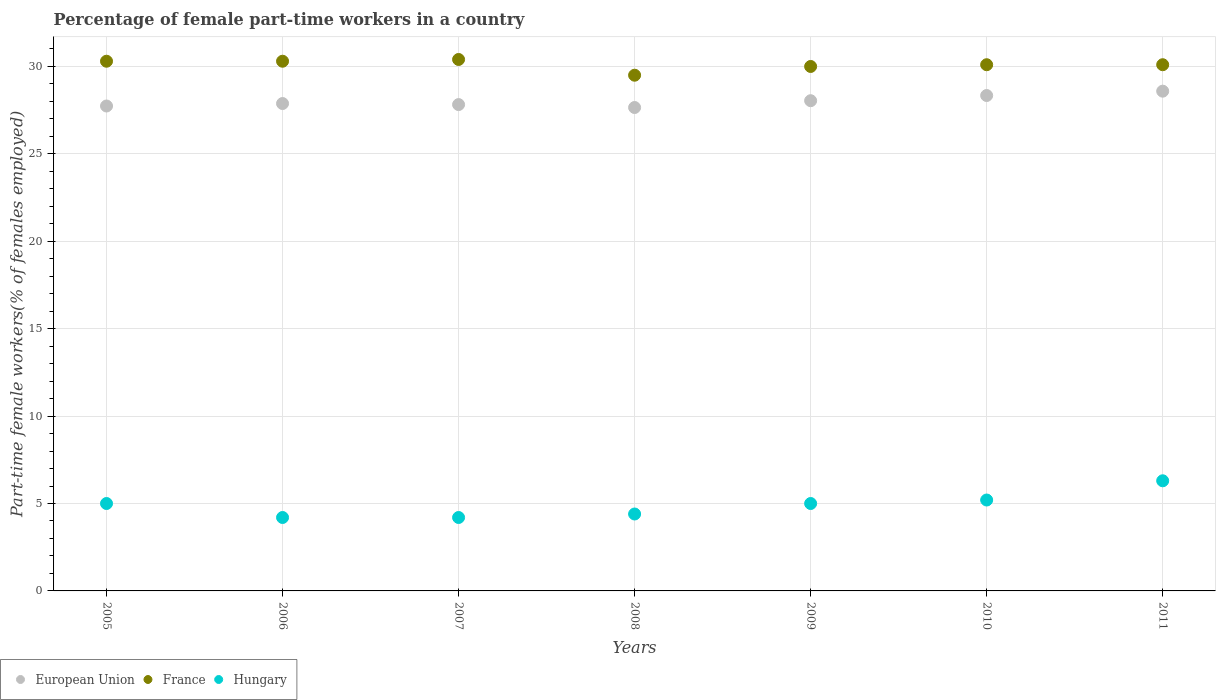What is the percentage of female part-time workers in Hungary in 2007?
Provide a succinct answer. 4.2. Across all years, what is the maximum percentage of female part-time workers in European Union?
Provide a succinct answer. 28.59. Across all years, what is the minimum percentage of female part-time workers in France?
Give a very brief answer. 29.5. What is the total percentage of female part-time workers in Hungary in the graph?
Your response must be concise. 34.3. What is the difference between the percentage of female part-time workers in Hungary in 2009 and that in 2010?
Ensure brevity in your answer.  -0.2. What is the difference between the percentage of female part-time workers in France in 2011 and the percentage of female part-time workers in European Union in 2005?
Make the answer very short. 2.36. What is the average percentage of female part-time workers in European Union per year?
Provide a short and direct response. 28.01. In the year 2007, what is the difference between the percentage of female part-time workers in European Union and percentage of female part-time workers in Hungary?
Make the answer very short. 23.62. What is the ratio of the percentage of female part-time workers in Hungary in 2007 to that in 2008?
Your response must be concise. 0.95. Is the percentage of female part-time workers in European Union in 2006 less than that in 2008?
Your answer should be compact. No. What is the difference between the highest and the second highest percentage of female part-time workers in France?
Offer a terse response. 0.1. What is the difference between the highest and the lowest percentage of female part-time workers in European Union?
Ensure brevity in your answer.  0.93. In how many years, is the percentage of female part-time workers in European Union greater than the average percentage of female part-time workers in European Union taken over all years?
Ensure brevity in your answer.  3. Is it the case that in every year, the sum of the percentage of female part-time workers in Hungary and percentage of female part-time workers in European Union  is greater than the percentage of female part-time workers in France?
Give a very brief answer. Yes. How many dotlines are there?
Ensure brevity in your answer.  3. How many years are there in the graph?
Give a very brief answer. 7. Are the values on the major ticks of Y-axis written in scientific E-notation?
Provide a succinct answer. No. Does the graph contain grids?
Offer a terse response. Yes. How many legend labels are there?
Your answer should be compact. 3. How are the legend labels stacked?
Provide a short and direct response. Horizontal. What is the title of the graph?
Ensure brevity in your answer.  Percentage of female part-time workers in a country. What is the label or title of the Y-axis?
Give a very brief answer. Part-time female workers(% of females employed). What is the Part-time female workers(% of females employed) in European Union in 2005?
Offer a very short reply. 27.74. What is the Part-time female workers(% of females employed) in France in 2005?
Ensure brevity in your answer.  30.3. What is the Part-time female workers(% of females employed) of Hungary in 2005?
Your response must be concise. 5. What is the Part-time female workers(% of females employed) in European Union in 2006?
Ensure brevity in your answer.  27.88. What is the Part-time female workers(% of females employed) in France in 2006?
Keep it short and to the point. 30.3. What is the Part-time female workers(% of females employed) in Hungary in 2006?
Make the answer very short. 4.2. What is the Part-time female workers(% of females employed) in European Union in 2007?
Give a very brief answer. 27.82. What is the Part-time female workers(% of females employed) in France in 2007?
Make the answer very short. 30.4. What is the Part-time female workers(% of females employed) of Hungary in 2007?
Offer a terse response. 4.2. What is the Part-time female workers(% of females employed) in European Union in 2008?
Give a very brief answer. 27.65. What is the Part-time female workers(% of females employed) of France in 2008?
Ensure brevity in your answer.  29.5. What is the Part-time female workers(% of females employed) of Hungary in 2008?
Give a very brief answer. 4.4. What is the Part-time female workers(% of females employed) of European Union in 2009?
Give a very brief answer. 28.04. What is the Part-time female workers(% of females employed) in France in 2009?
Your answer should be very brief. 30. What is the Part-time female workers(% of females employed) in Hungary in 2009?
Provide a short and direct response. 5. What is the Part-time female workers(% of females employed) of European Union in 2010?
Make the answer very short. 28.34. What is the Part-time female workers(% of females employed) of France in 2010?
Your answer should be compact. 30.1. What is the Part-time female workers(% of females employed) of Hungary in 2010?
Offer a very short reply. 5.2. What is the Part-time female workers(% of females employed) in European Union in 2011?
Your answer should be very brief. 28.59. What is the Part-time female workers(% of females employed) in France in 2011?
Your response must be concise. 30.1. What is the Part-time female workers(% of females employed) in Hungary in 2011?
Your answer should be compact. 6.3. Across all years, what is the maximum Part-time female workers(% of females employed) in European Union?
Provide a short and direct response. 28.59. Across all years, what is the maximum Part-time female workers(% of females employed) of France?
Offer a very short reply. 30.4. Across all years, what is the maximum Part-time female workers(% of females employed) of Hungary?
Ensure brevity in your answer.  6.3. Across all years, what is the minimum Part-time female workers(% of females employed) in European Union?
Give a very brief answer. 27.65. Across all years, what is the minimum Part-time female workers(% of females employed) in France?
Your answer should be compact. 29.5. Across all years, what is the minimum Part-time female workers(% of females employed) in Hungary?
Offer a terse response. 4.2. What is the total Part-time female workers(% of females employed) in European Union in the graph?
Make the answer very short. 196.06. What is the total Part-time female workers(% of females employed) in France in the graph?
Provide a short and direct response. 210.7. What is the total Part-time female workers(% of females employed) in Hungary in the graph?
Provide a short and direct response. 34.3. What is the difference between the Part-time female workers(% of females employed) of European Union in 2005 and that in 2006?
Ensure brevity in your answer.  -0.14. What is the difference between the Part-time female workers(% of females employed) of France in 2005 and that in 2006?
Your answer should be compact. 0. What is the difference between the Part-time female workers(% of females employed) of European Union in 2005 and that in 2007?
Make the answer very short. -0.08. What is the difference between the Part-time female workers(% of females employed) in France in 2005 and that in 2007?
Ensure brevity in your answer.  -0.1. What is the difference between the Part-time female workers(% of females employed) of Hungary in 2005 and that in 2007?
Provide a succinct answer. 0.8. What is the difference between the Part-time female workers(% of females employed) in European Union in 2005 and that in 2008?
Offer a terse response. 0.09. What is the difference between the Part-time female workers(% of females employed) in France in 2005 and that in 2008?
Offer a very short reply. 0.8. What is the difference between the Part-time female workers(% of females employed) of European Union in 2005 and that in 2009?
Your response must be concise. -0.3. What is the difference between the Part-time female workers(% of females employed) of European Union in 2005 and that in 2010?
Provide a succinct answer. -0.6. What is the difference between the Part-time female workers(% of females employed) in Hungary in 2005 and that in 2010?
Ensure brevity in your answer.  -0.2. What is the difference between the Part-time female workers(% of females employed) of European Union in 2005 and that in 2011?
Make the answer very short. -0.85. What is the difference between the Part-time female workers(% of females employed) of France in 2005 and that in 2011?
Your response must be concise. 0.2. What is the difference between the Part-time female workers(% of females employed) in Hungary in 2005 and that in 2011?
Provide a succinct answer. -1.3. What is the difference between the Part-time female workers(% of females employed) of European Union in 2006 and that in 2007?
Keep it short and to the point. 0.06. What is the difference between the Part-time female workers(% of females employed) in France in 2006 and that in 2007?
Give a very brief answer. -0.1. What is the difference between the Part-time female workers(% of females employed) in European Union in 2006 and that in 2008?
Keep it short and to the point. 0.23. What is the difference between the Part-time female workers(% of females employed) of Hungary in 2006 and that in 2008?
Your answer should be compact. -0.2. What is the difference between the Part-time female workers(% of females employed) of European Union in 2006 and that in 2009?
Give a very brief answer. -0.16. What is the difference between the Part-time female workers(% of females employed) of France in 2006 and that in 2009?
Offer a very short reply. 0.3. What is the difference between the Part-time female workers(% of females employed) of European Union in 2006 and that in 2010?
Your answer should be compact. -0.46. What is the difference between the Part-time female workers(% of females employed) in France in 2006 and that in 2010?
Provide a short and direct response. 0.2. What is the difference between the Part-time female workers(% of females employed) of European Union in 2006 and that in 2011?
Provide a succinct answer. -0.71. What is the difference between the Part-time female workers(% of females employed) in European Union in 2007 and that in 2008?
Offer a very short reply. 0.17. What is the difference between the Part-time female workers(% of females employed) of France in 2007 and that in 2008?
Keep it short and to the point. 0.9. What is the difference between the Part-time female workers(% of females employed) of European Union in 2007 and that in 2009?
Your answer should be compact. -0.22. What is the difference between the Part-time female workers(% of females employed) in Hungary in 2007 and that in 2009?
Make the answer very short. -0.8. What is the difference between the Part-time female workers(% of females employed) of European Union in 2007 and that in 2010?
Your answer should be very brief. -0.52. What is the difference between the Part-time female workers(% of females employed) in France in 2007 and that in 2010?
Make the answer very short. 0.3. What is the difference between the Part-time female workers(% of females employed) of European Union in 2007 and that in 2011?
Your answer should be compact. -0.77. What is the difference between the Part-time female workers(% of females employed) of Hungary in 2007 and that in 2011?
Provide a short and direct response. -2.1. What is the difference between the Part-time female workers(% of females employed) of European Union in 2008 and that in 2009?
Your answer should be very brief. -0.39. What is the difference between the Part-time female workers(% of females employed) in European Union in 2008 and that in 2010?
Make the answer very short. -0.69. What is the difference between the Part-time female workers(% of females employed) of Hungary in 2008 and that in 2010?
Offer a very short reply. -0.8. What is the difference between the Part-time female workers(% of females employed) in European Union in 2008 and that in 2011?
Provide a succinct answer. -0.93. What is the difference between the Part-time female workers(% of females employed) in Hungary in 2008 and that in 2011?
Make the answer very short. -1.9. What is the difference between the Part-time female workers(% of females employed) of European Union in 2009 and that in 2010?
Offer a very short reply. -0.3. What is the difference between the Part-time female workers(% of females employed) in France in 2009 and that in 2010?
Your response must be concise. -0.1. What is the difference between the Part-time female workers(% of females employed) in European Union in 2009 and that in 2011?
Offer a terse response. -0.55. What is the difference between the Part-time female workers(% of females employed) in France in 2009 and that in 2011?
Make the answer very short. -0.1. What is the difference between the Part-time female workers(% of females employed) in European Union in 2010 and that in 2011?
Your response must be concise. -0.25. What is the difference between the Part-time female workers(% of females employed) in European Union in 2005 and the Part-time female workers(% of females employed) in France in 2006?
Give a very brief answer. -2.56. What is the difference between the Part-time female workers(% of females employed) of European Union in 2005 and the Part-time female workers(% of females employed) of Hungary in 2006?
Your answer should be compact. 23.54. What is the difference between the Part-time female workers(% of females employed) in France in 2005 and the Part-time female workers(% of females employed) in Hungary in 2006?
Offer a very short reply. 26.1. What is the difference between the Part-time female workers(% of females employed) in European Union in 2005 and the Part-time female workers(% of females employed) in France in 2007?
Provide a short and direct response. -2.66. What is the difference between the Part-time female workers(% of females employed) in European Union in 2005 and the Part-time female workers(% of females employed) in Hungary in 2007?
Make the answer very short. 23.54. What is the difference between the Part-time female workers(% of females employed) of France in 2005 and the Part-time female workers(% of females employed) of Hungary in 2007?
Your answer should be very brief. 26.1. What is the difference between the Part-time female workers(% of females employed) of European Union in 2005 and the Part-time female workers(% of females employed) of France in 2008?
Your answer should be very brief. -1.76. What is the difference between the Part-time female workers(% of females employed) of European Union in 2005 and the Part-time female workers(% of females employed) of Hungary in 2008?
Provide a short and direct response. 23.34. What is the difference between the Part-time female workers(% of females employed) in France in 2005 and the Part-time female workers(% of females employed) in Hungary in 2008?
Offer a terse response. 25.9. What is the difference between the Part-time female workers(% of females employed) of European Union in 2005 and the Part-time female workers(% of females employed) of France in 2009?
Keep it short and to the point. -2.26. What is the difference between the Part-time female workers(% of females employed) in European Union in 2005 and the Part-time female workers(% of females employed) in Hungary in 2009?
Your answer should be compact. 22.74. What is the difference between the Part-time female workers(% of females employed) in France in 2005 and the Part-time female workers(% of females employed) in Hungary in 2009?
Your response must be concise. 25.3. What is the difference between the Part-time female workers(% of females employed) of European Union in 2005 and the Part-time female workers(% of females employed) of France in 2010?
Your answer should be very brief. -2.36. What is the difference between the Part-time female workers(% of females employed) of European Union in 2005 and the Part-time female workers(% of females employed) of Hungary in 2010?
Provide a short and direct response. 22.54. What is the difference between the Part-time female workers(% of females employed) in France in 2005 and the Part-time female workers(% of females employed) in Hungary in 2010?
Offer a terse response. 25.1. What is the difference between the Part-time female workers(% of females employed) in European Union in 2005 and the Part-time female workers(% of females employed) in France in 2011?
Keep it short and to the point. -2.36. What is the difference between the Part-time female workers(% of females employed) of European Union in 2005 and the Part-time female workers(% of females employed) of Hungary in 2011?
Provide a succinct answer. 21.44. What is the difference between the Part-time female workers(% of females employed) in European Union in 2006 and the Part-time female workers(% of females employed) in France in 2007?
Your answer should be compact. -2.52. What is the difference between the Part-time female workers(% of females employed) in European Union in 2006 and the Part-time female workers(% of females employed) in Hungary in 2007?
Your response must be concise. 23.68. What is the difference between the Part-time female workers(% of females employed) of France in 2006 and the Part-time female workers(% of females employed) of Hungary in 2007?
Offer a very short reply. 26.1. What is the difference between the Part-time female workers(% of females employed) of European Union in 2006 and the Part-time female workers(% of females employed) of France in 2008?
Give a very brief answer. -1.62. What is the difference between the Part-time female workers(% of females employed) of European Union in 2006 and the Part-time female workers(% of females employed) of Hungary in 2008?
Keep it short and to the point. 23.48. What is the difference between the Part-time female workers(% of females employed) of France in 2006 and the Part-time female workers(% of females employed) of Hungary in 2008?
Give a very brief answer. 25.9. What is the difference between the Part-time female workers(% of females employed) of European Union in 2006 and the Part-time female workers(% of females employed) of France in 2009?
Your response must be concise. -2.12. What is the difference between the Part-time female workers(% of females employed) in European Union in 2006 and the Part-time female workers(% of females employed) in Hungary in 2009?
Offer a terse response. 22.88. What is the difference between the Part-time female workers(% of females employed) in France in 2006 and the Part-time female workers(% of females employed) in Hungary in 2009?
Your answer should be very brief. 25.3. What is the difference between the Part-time female workers(% of females employed) in European Union in 2006 and the Part-time female workers(% of females employed) in France in 2010?
Make the answer very short. -2.22. What is the difference between the Part-time female workers(% of females employed) in European Union in 2006 and the Part-time female workers(% of females employed) in Hungary in 2010?
Your answer should be very brief. 22.68. What is the difference between the Part-time female workers(% of females employed) in France in 2006 and the Part-time female workers(% of females employed) in Hungary in 2010?
Offer a terse response. 25.1. What is the difference between the Part-time female workers(% of females employed) of European Union in 2006 and the Part-time female workers(% of females employed) of France in 2011?
Your answer should be compact. -2.22. What is the difference between the Part-time female workers(% of females employed) in European Union in 2006 and the Part-time female workers(% of females employed) in Hungary in 2011?
Provide a succinct answer. 21.58. What is the difference between the Part-time female workers(% of females employed) in France in 2006 and the Part-time female workers(% of females employed) in Hungary in 2011?
Provide a succinct answer. 24. What is the difference between the Part-time female workers(% of females employed) of European Union in 2007 and the Part-time female workers(% of females employed) of France in 2008?
Offer a terse response. -1.68. What is the difference between the Part-time female workers(% of females employed) of European Union in 2007 and the Part-time female workers(% of females employed) of Hungary in 2008?
Your answer should be compact. 23.42. What is the difference between the Part-time female workers(% of females employed) in France in 2007 and the Part-time female workers(% of females employed) in Hungary in 2008?
Provide a short and direct response. 26. What is the difference between the Part-time female workers(% of females employed) of European Union in 2007 and the Part-time female workers(% of females employed) of France in 2009?
Keep it short and to the point. -2.18. What is the difference between the Part-time female workers(% of females employed) of European Union in 2007 and the Part-time female workers(% of females employed) of Hungary in 2009?
Your answer should be very brief. 22.82. What is the difference between the Part-time female workers(% of females employed) in France in 2007 and the Part-time female workers(% of females employed) in Hungary in 2009?
Your answer should be very brief. 25.4. What is the difference between the Part-time female workers(% of females employed) of European Union in 2007 and the Part-time female workers(% of females employed) of France in 2010?
Your answer should be compact. -2.28. What is the difference between the Part-time female workers(% of females employed) of European Union in 2007 and the Part-time female workers(% of females employed) of Hungary in 2010?
Provide a succinct answer. 22.62. What is the difference between the Part-time female workers(% of females employed) in France in 2007 and the Part-time female workers(% of females employed) in Hungary in 2010?
Provide a succinct answer. 25.2. What is the difference between the Part-time female workers(% of females employed) in European Union in 2007 and the Part-time female workers(% of females employed) in France in 2011?
Provide a succinct answer. -2.28. What is the difference between the Part-time female workers(% of females employed) of European Union in 2007 and the Part-time female workers(% of females employed) of Hungary in 2011?
Your response must be concise. 21.52. What is the difference between the Part-time female workers(% of females employed) in France in 2007 and the Part-time female workers(% of females employed) in Hungary in 2011?
Your response must be concise. 24.1. What is the difference between the Part-time female workers(% of females employed) in European Union in 2008 and the Part-time female workers(% of females employed) in France in 2009?
Offer a very short reply. -2.35. What is the difference between the Part-time female workers(% of females employed) of European Union in 2008 and the Part-time female workers(% of females employed) of Hungary in 2009?
Your answer should be very brief. 22.65. What is the difference between the Part-time female workers(% of females employed) in France in 2008 and the Part-time female workers(% of females employed) in Hungary in 2009?
Your answer should be compact. 24.5. What is the difference between the Part-time female workers(% of females employed) of European Union in 2008 and the Part-time female workers(% of females employed) of France in 2010?
Make the answer very short. -2.45. What is the difference between the Part-time female workers(% of females employed) of European Union in 2008 and the Part-time female workers(% of females employed) of Hungary in 2010?
Make the answer very short. 22.45. What is the difference between the Part-time female workers(% of females employed) of France in 2008 and the Part-time female workers(% of females employed) of Hungary in 2010?
Give a very brief answer. 24.3. What is the difference between the Part-time female workers(% of females employed) in European Union in 2008 and the Part-time female workers(% of females employed) in France in 2011?
Offer a very short reply. -2.45. What is the difference between the Part-time female workers(% of females employed) in European Union in 2008 and the Part-time female workers(% of females employed) in Hungary in 2011?
Give a very brief answer. 21.35. What is the difference between the Part-time female workers(% of females employed) in France in 2008 and the Part-time female workers(% of females employed) in Hungary in 2011?
Your answer should be compact. 23.2. What is the difference between the Part-time female workers(% of females employed) in European Union in 2009 and the Part-time female workers(% of females employed) in France in 2010?
Your response must be concise. -2.06. What is the difference between the Part-time female workers(% of females employed) of European Union in 2009 and the Part-time female workers(% of females employed) of Hungary in 2010?
Keep it short and to the point. 22.84. What is the difference between the Part-time female workers(% of females employed) in France in 2009 and the Part-time female workers(% of females employed) in Hungary in 2010?
Keep it short and to the point. 24.8. What is the difference between the Part-time female workers(% of females employed) of European Union in 2009 and the Part-time female workers(% of females employed) of France in 2011?
Your answer should be compact. -2.06. What is the difference between the Part-time female workers(% of females employed) in European Union in 2009 and the Part-time female workers(% of females employed) in Hungary in 2011?
Provide a short and direct response. 21.74. What is the difference between the Part-time female workers(% of females employed) in France in 2009 and the Part-time female workers(% of females employed) in Hungary in 2011?
Provide a short and direct response. 23.7. What is the difference between the Part-time female workers(% of females employed) of European Union in 2010 and the Part-time female workers(% of females employed) of France in 2011?
Ensure brevity in your answer.  -1.76. What is the difference between the Part-time female workers(% of females employed) in European Union in 2010 and the Part-time female workers(% of females employed) in Hungary in 2011?
Make the answer very short. 22.04. What is the difference between the Part-time female workers(% of females employed) of France in 2010 and the Part-time female workers(% of females employed) of Hungary in 2011?
Your answer should be compact. 23.8. What is the average Part-time female workers(% of females employed) of European Union per year?
Give a very brief answer. 28.01. What is the average Part-time female workers(% of females employed) in France per year?
Your answer should be compact. 30.1. In the year 2005, what is the difference between the Part-time female workers(% of females employed) in European Union and Part-time female workers(% of females employed) in France?
Your answer should be very brief. -2.56. In the year 2005, what is the difference between the Part-time female workers(% of females employed) in European Union and Part-time female workers(% of females employed) in Hungary?
Give a very brief answer. 22.74. In the year 2005, what is the difference between the Part-time female workers(% of females employed) of France and Part-time female workers(% of females employed) of Hungary?
Your answer should be compact. 25.3. In the year 2006, what is the difference between the Part-time female workers(% of females employed) in European Union and Part-time female workers(% of females employed) in France?
Keep it short and to the point. -2.42. In the year 2006, what is the difference between the Part-time female workers(% of females employed) of European Union and Part-time female workers(% of females employed) of Hungary?
Make the answer very short. 23.68. In the year 2006, what is the difference between the Part-time female workers(% of females employed) in France and Part-time female workers(% of females employed) in Hungary?
Ensure brevity in your answer.  26.1. In the year 2007, what is the difference between the Part-time female workers(% of females employed) in European Union and Part-time female workers(% of females employed) in France?
Offer a very short reply. -2.58. In the year 2007, what is the difference between the Part-time female workers(% of females employed) in European Union and Part-time female workers(% of females employed) in Hungary?
Offer a very short reply. 23.62. In the year 2007, what is the difference between the Part-time female workers(% of females employed) in France and Part-time female workers(% of females employed) in Hungary?
Make the answer very short. 26.2. In the year 2008, what is the difference between the Part-time female workers(% of females employed) of European Union and Part-time female workers(% of females employed) of France?
Make the answer very short. -1.85. In the year 2008, what is the difference between the Part-time female workers(% of females employed) in European Union and Part-time female workers(% of females employed) in Hungary?
Give a very brief answer. 23.25. In the year 2008, what is the difference between the Part-time female workers(% of females employed) in France and Part-time female workers(% of females employed) in Hungary?
Your answer should be very brief. 25.1. In the year 2009, what is the difference between the Part-time female workers(% of females employed) in European Union and Part-time female workers(% of females employed) in France?
Ensure brevity in your answer.  -1.96. In the year 2009, what is the difference between the Part-time female workers(% of females employed) in European Union and Part-time female workers(% of females employed) in Hungary?
Give a very brief answer. 23.04. In the year 2009, what is the difference between the Part-time female workers(% of females employed) of France and Part-time female workers(% of females employed) of Hungary?
Give a very brief answer. 25. In the year 2010, what is the difference between the Part-time female workers(% of females employed) of European Union and Part-time female workers(% of females employed) of France?
Provide a short and direct response. -1.76. In the year 2010, what is the difference between the Part-time female workers(% of females employed) in European Union and Part-time female workers(% of females employed) in Hungary?
Offer a very short reply. 23.14. In the year 2010, what is the difference between the Part-time female workers(% of females employed) of France and Part-time female workers(% of females employed) of Hungary?
Keep it short and to the point. 24.9. In the year 2011, what is the difference between the Part-time female workers(% of females employed) in European Union and Part-time female workers(% of females employed) in France?
Offer a very short reply. -1.51. In the year 2011, what is the difference between the Part-time female workers(% of females employed) in European Union and Part-time female workers(% of females employed) in Hungary?
Offer a terse response. 22.29. In the year 2011, what is the difference between the Part-time female workers(% of females employed) in France and Part-time female workers(% of females employed) in Hungary?
Offer a terse response. 23.8. What is the ratio of the Part-time female workers(% of females employed) of European Union in 2005 to that in 2006?
Provide a succinct answer. 0.99. What is the ratio of the Part-time female workers(% of females employed) in Hungary in 2005 to that in 2006?
Ensure brevity in your answer.  1.19. What is the ratio of the Part-time female workers(% of females employed) in European Union in 2005 to that in 2007?
Your answer should be compact. 1. What is the ratio of the Part-time female workers(% of females employed) of Hungary in 2005 to that in 2007?
Offer a very short reply. 1.19. What is the ratio of the Part-time female workers(% of females employed) in European Union in 2005 to that in 2008?
Your answer should be very brief. 1. What is the ratio of the Part-time female workers(% of females employed) of France in 2005 to that in 2008?
Give a very brief answer. 1.03. What is the ratio of the Part-time female workers(% of females employed) in Hungary in 2005 to that in 2008?
Offer a very short reply. 1.14. What is the ratio of the Part-time female workers(% of females employed) in European Union in 2005 to that in 2009?
Your answer should be very brief. 0.99. What is the ratio of the Part-time female workers(% of females employed) in France in 2005 to that in 2009?
Your response must be concise. 1.01. What is the ratio of the Part-time female workers(% of females employed) in Hungary in 2005 to that in 2009?
Your answer should be very brief. 1. What is the ratio of the Part-time female workers(% of females employed) of European Union in 2005 to that in 2010?
Your answer should be very brief. 0.98. What is the ratio of the Part-time female workers(% of females employed) of France in 2005 to that in 2010?
Give a very brief answer. 1.01. What is the ratio of the Part-time female workers(% of females employed) in Hungary in 2005 to that in 2010?
Provide a succinct answer. 0.96. What is the ratio of the Part-time female workers(% of females employed) in European Union in 2005 to that in 2011?
Give a very brief answer. 0.97. What is the ratio of the Part-time female workers(% of females employed) of France in 2005 to that in 2011?
Your response must be concise. 1.01. What is the ratio of the Part-time female workers(% of females employed) of Hungary in 2005 to that in 2011?
Provide a succinct answer. 0.79. What is the ratio of the Part-time female workers(% of females employed) of France in 2006 to that in 2007?
Your answer should be very brief. 1. What is the ratio of the Part-time female workers(% of females employed) in Hungary in 2006 to that in 2007?
Make the answer very short. 1. What is the ratio of the Part-time female workers(% of females employed) in European Union in 2006 to that in 2008?
Offer a terse response. 1.01. What is the ratio of the Part-time female workers(% of females employed) in France in 2006 to that in 2008?
Your answer should be compact. 1.03. What is the ratio of the Part-time female workers(% of females employed) of Hungary in 2006 to that in 2008?
Your answer should be compact. 0.95. What is the ratio of the Part-time female workers(% of females employed) of European Union in 2006 to that in 2009?
Offer a terse response. 0.99. What is the ratio of the Part-time female workers(% of females employed) of France in 2006 to that in 2009?
Keep it short and to the point. 1.01. What is the ratio of the Part-time female workers(% of females employed) in Hungary in 2006 to that in 2009?
Offer a very short reply. 0.84. What is the ratio of the Part-time female workers(% of females employed) of European Union in 2006 to that in 2010?
Offer a terse response. 0.98. What is the ratio of the Part-time female workers(% of females employed) of France in 2006 to that in 2010?
Your response must be concise. 1.01. What is the ratio of the Part-time female workers(% of females employed) in Hungary in 2006 to that in 2010?
Make the answer very short. 0.81. What is the ratio of the Part-time female workers(% of females employed) of European Union in 2006 to that in 2011?
Provide a succinct answer. 0.98. What is the ratio of the Part-time female workers(% of females employed) of France in 2006 to that in 2011?
Your answer should be very brief. 1.01. What is the ratio of the Part-time female workers(% of females employed) in France in 2007 to that in 2008?
Your answer should be very brief. 1.03. What is the ratio of the Part-time female workers(% of females employed) in Hungary in 2007 to that in 2008?
Offer a very short reply. 0.95. What is the ratio of the Part-time female workers(% of females employed) in France in 2007 to that in 2009?
Make the answer very short. 1.01. What is the ratio of the Part-time female workers(% of females employed) in Hungary in 2007 to that in 2009?
Make the answer very short. 0.84. What is the ratio of the Part-time female workers(% of females employed) in European Union in 2007 to that in 2010?
Your answer should be very brief. 0.98. What is the ratio of the Part-time female workers(% of females employed) in Hungary in 2007 to that in 2010?
Your answer should be compact. 0.81. What is the ratio of the Part-time female workers(% of females employed) in European Union in 2007 to that in 2011?
Offer a terse response. 0.97. What is the ratio of the Part-time female workers(% of females employed) in European Union in 2008 to that in 2009?
Your response must be concise. 0.99. What is the ratio of the Part-time female workers(% of females employed) of France in 2008 to that in 2009?
Your answer should be very brief. 0.98. What is the ratio of the Part-time female workers(% of females employed) of Hungary in 2008 to that in 2009?
Offer a very short reply. 0.88. What is the ratio of the Part-time female workers(% of females employed) in European Union in 2008 to that in 2010?
Your answer should be compact. 0.98. What is the ratio of the Part-time female workers(% of females employed) of France in 2008 to that in 2010?
Offer a terse response. 0.98. What is the ratio of the Part-time female workers(% of females employed) in Hungary in 2008 to that in 2010?
Make the answer very short. 0.85. What is the ratio of the Part-time female workers(% of females employed) in European Union in 2008 to that in 2011?
Your answer should be very brief. 0.97. What is the ratio of the Part-time female workers(% of females employed) in France in 2008 to that in 2011?
Your answer should be compact. 0.98. What is the ratio of the Part-time female workers(% of females employed) in Hungary in 2008 to that in 2011?
Give a very brief answer. 0.7. What is the ratio of the Part-time female workers(% of females employed) of Hungary in 2009 to that in 2010?
Offer a very short reply. 0.96. What is the ratio of the Part-time female workers(% of females employed) in European Union in 2009 to that in 2011?
Your answer should be compact. 0.98. What is the ratio of the Part-time female workers(% of females employed) of France in 2009 to that in 2011?
Provide a short and direct response. 1. What is the ratio of the Part-time female workers(% of females employed) of Hungary in 2009 to that in 2011?
Your answer should be compact. 0.79. What is the ratio of the Part-time female workers(% of females employed) of France in 2010 to that in 2011?
Offer a terse response. 1. What is the ratio of the Part-time female workers(% of females employed) of Hungary in 2010 to that in 2011?
Offer a terse response. 0.83. What is the difference between the highest and the second highest Part-time female workers(% of females employed) in European Union?
Offer a very short reply. 0.25. What is the difference between the highest and the lowest Part-time female workers(% of females employed) of European Union?
Your answer should be compact. 0.93. What is the difference between the highest and the lowest Part-time female workers(% of females employed) in Hungary?
Offer a terse response. 2.1. 